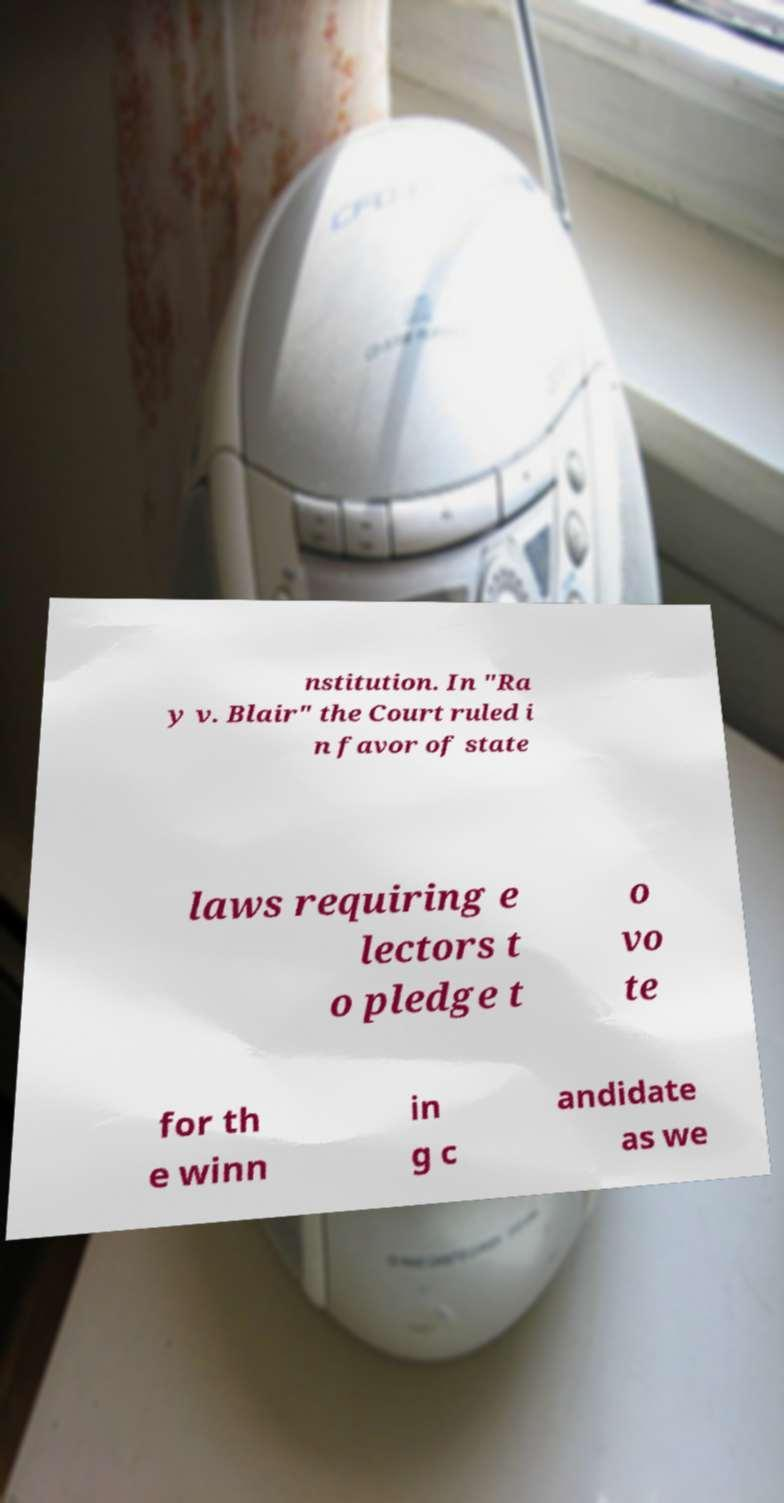Could you extract and type out the text from this image? nstitution. In "Ra y v. Blair" the Court ruled i n favor of state laws requiring e lectors t o pledge t o vo te for th e winn in g c andidate as we 